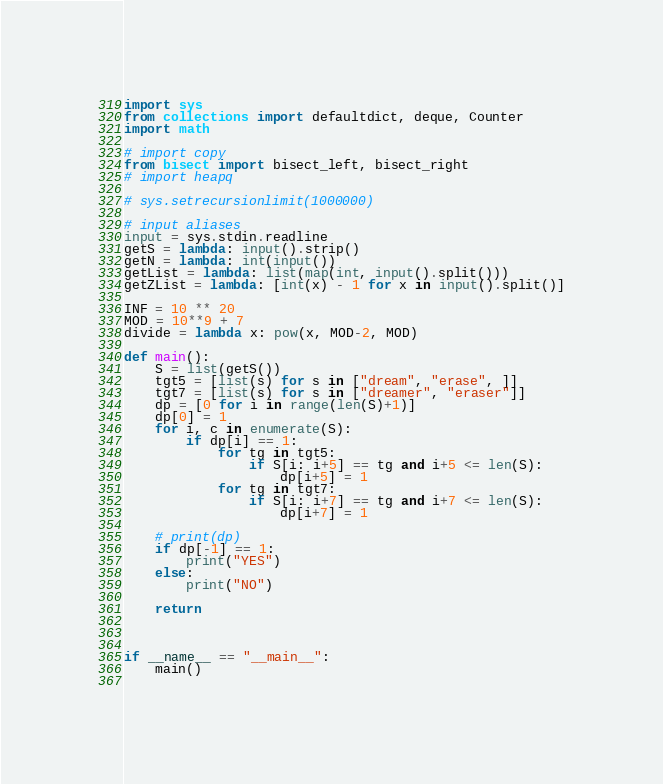<code> <loc_0><loc_0><loc_500><loc_500><_Python_>import sys
from collections import defaultdict, deque, Counter
import math
 
# import copy
from bisect import bisect_left, bisect_right
# import heapq
 
# sys.setrecursionlimit(1000000)
 
# input aliases
input = sys.stdin.readline
getS = lambda: input().strip()
getN = lambda: int(input())
getList = lambda: list(map(int, input().split()))
getZList = lambda: [int(x) - 1 for x in input().split()]
 
INF = 10 ** 20
MOD = 10**9 + 7
divide = lambda x: pow(x, MOD-2, MOD)
 
def main():
    S = list(getS())
    tgt5 = [list(s) for s in ["dream", "erase", ]]
    tgt7 = [list(s) for s in ["dreamer", "eraser"]]
    dp = [0 for i in range(len(S)+1)]
    dp[0] = 1
    for i, c in enumerate(S):
        if dp[i] == 1:
            for tg in tgt5:
                if S[i: i+5] == tg and i+5 <= len(S):
                    dp[i+5] = 1
            for tg in tgt7:
                if S[i: i+7] == tg and i+7 <= len(S):
                    dp[i+7] = 1

    # print(dp)
    if dp[-1] == 1:
        print("YES")
    else: 
        print("NO")

    return


 
if __name__ == "__main__":
    main()
   </code> 